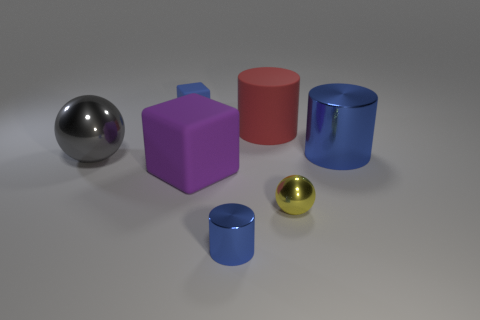What number of other things are there of the same size as the blue matte object?
Your answer should be compact. 2. What is the material of the tiny blue thing that is on the right side of the tiny blue thing behind the large blue metal cylinder?
Provide a succinct answer. Metal. There is a red matte thing; does it have the same size as the rubber block that is behind the gray shiny thing?
Provide a short and direct response. No. Is there a small rubber ball that has the same color as the tiny matte cube?
Your answer should be compact. No. How many small objects are balls or blue shiny balls?
Ensure brevity in your answer.  1. How many big yellow cubes are there?
Ensure brevity in your answer.  0. What material is the tiny blue block behind the purple rubber cube?
Your response must be concise. Rubber. There is a large purple object; are there any blocks in front of it?
Your answer should be very brief. No. Do the blue cube and the rubber cylinder have the same size?
Keep it short and to the point. No. What number of tiny blue things have the same material as the big gray sphere?
Provide a short and direct response. 1. 